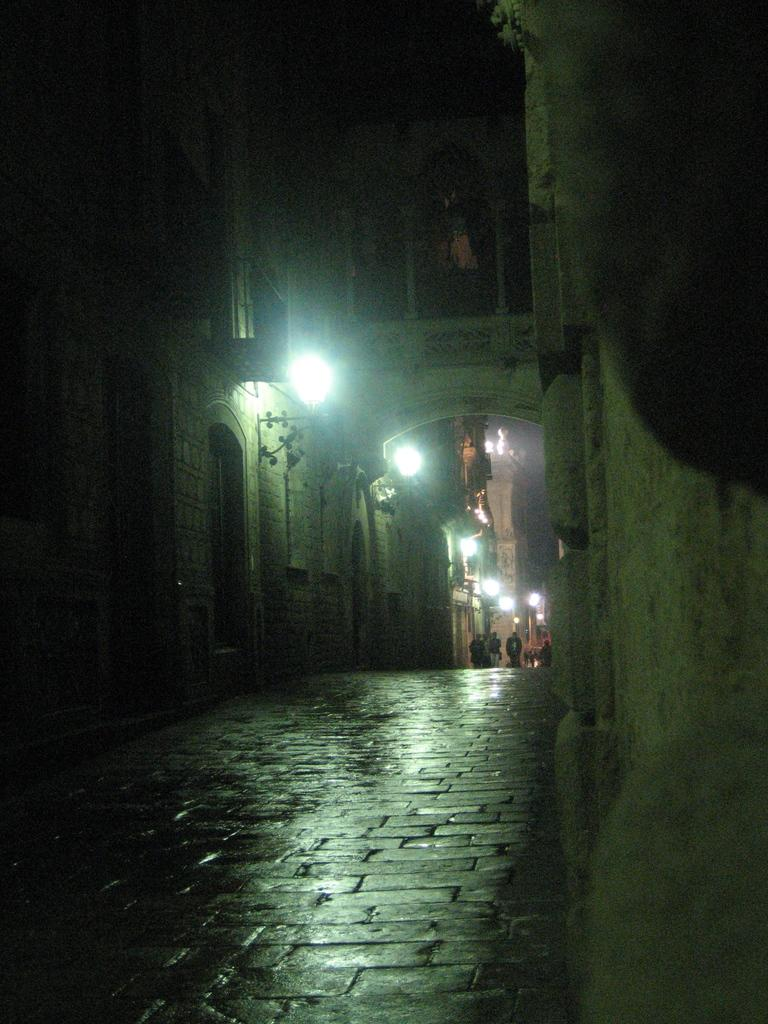What is the main feature of the image? There is a road in the image. What can be seen near the road? There are buildings near the road. Are there any additional features near the road? Lights are visible near the road. What else can be observed in the background of the image? There is a group of people in the background of the image. How many babies are present in the image? There are no babies visible in the image. What type of downtown area is depicted in the image? The image does not depict a downtown area; it features a road with buildings and lights. 